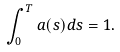Convert formula to latex. <formula><loc_0><loc_0><loc_500><loc_500>\int _ { 0 } ^ { T } a ( s ) d s = 1 .</formula> 